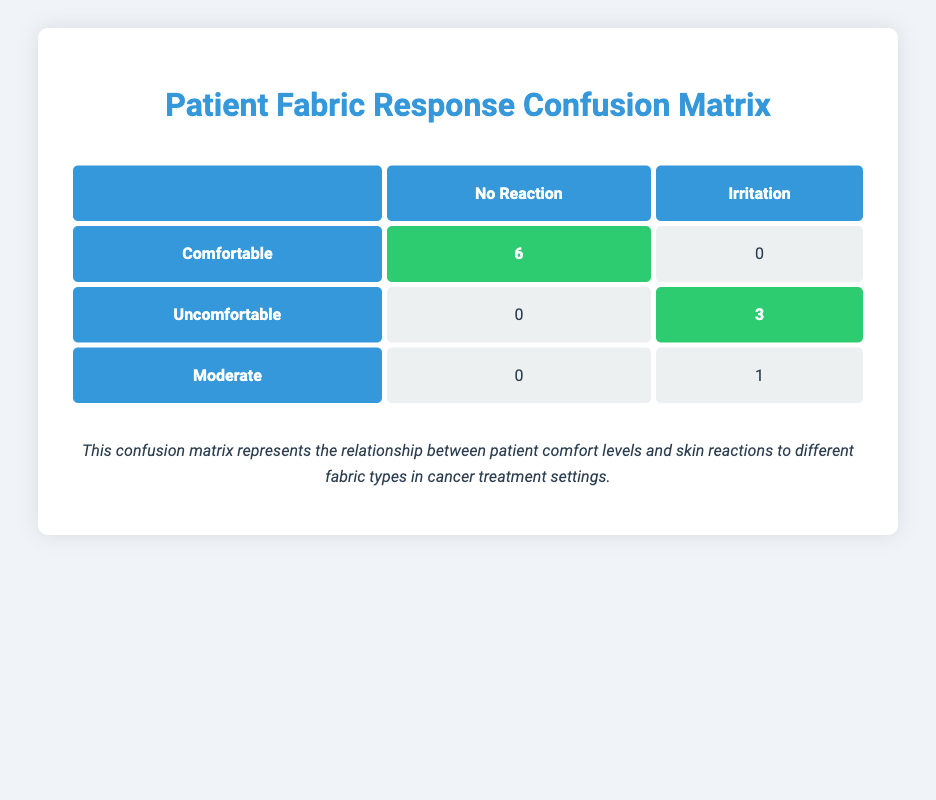What is the total number of patients who felt comfortable? From the table, under the "Comfortable" category, there are 6 patients who reported "No Reaction" and 0 patients who reported "Irritation." Thus, the total patients in the "Comfortable" group is 6 + 0 = 6.
Answer: 6 How many patients experienced skin irritation when they were uncomfortable? According to the table, under the "Uncomfortable" category, there are 0 patients with "No Reaction" and 3 patients with "Irritation." Therefore, 3 patients experienced skin irritation while feeling uncomfortable.
Answer: 3 Is there any patient who felt moderate comfort and had no skin reaction? The table indicates that under the "Moderate" category, there are 0 patients with "No Reaction." Hence, there are no patients who felt moderate comfort and had no skin reaction.
Answer: No What is the total number of patients who experienced skin irritation overall? To find the total, we need to sum the patients with skin irritation across all comfort levels. In the "Uncomfortable" category, there are 3 patients, and in the "Moderate" category, there is 1 patient with irritation. Thus, the total is 3 + 1 = 4.
Answer: 4 How many patients reported a comfortable experience without any skin reaction? The "Comfortable" row shows 6 patients reported "No Reaction." Thus, the number of patients who felt comfortable without any skin reaction is 6.
Answer: 6 Is it true that all comfortable patients had no skin reactions? Yes, according to the table, all 6 patients classified as "Comfortable" had "No Reaction," and there were 0 cases of irritation. Thus, this statement is true.
Answer: Yes What percentage of patients who felt uncomfortable experienced irritation? There are 3 patients who felt uncomfortable and experienced irritation. Since all patients in that category had irritation, we calculate the percentage as (3/3) * 100 = 100%.
Answer: 100% How many patients reported moderate comfort and experienced irritation? There is 1 patient listed under the "Moderate" comfort level with an "Irritation" reaction in the table. Thus, the number of patients who reported moderate comfort and had irritation is 1.
Answer: 1 